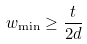Convert formula to latex. <formula><loc_0><loc_0><loc_500><loc_500>w _ { \min } \geq \frac { t } { 2 d }</formula> 